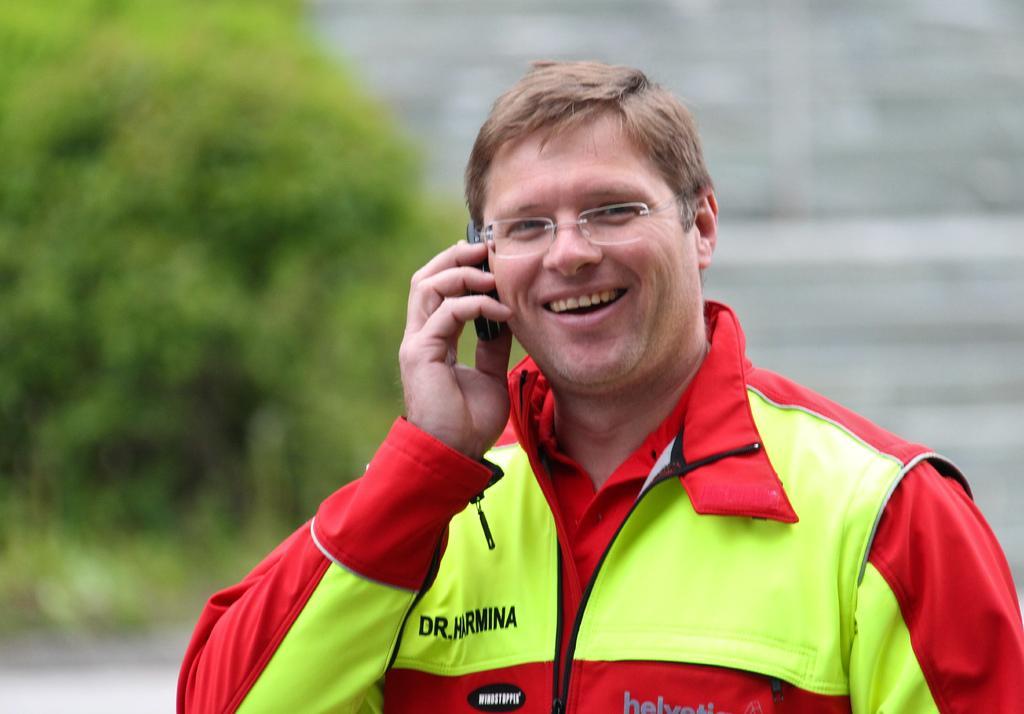Can you describe this image briefly? In this image we can see one man with smiling face wearing a spectacles holding a mobile phone and talking. There is one green tree on the left side of the image and the background is blurred. 